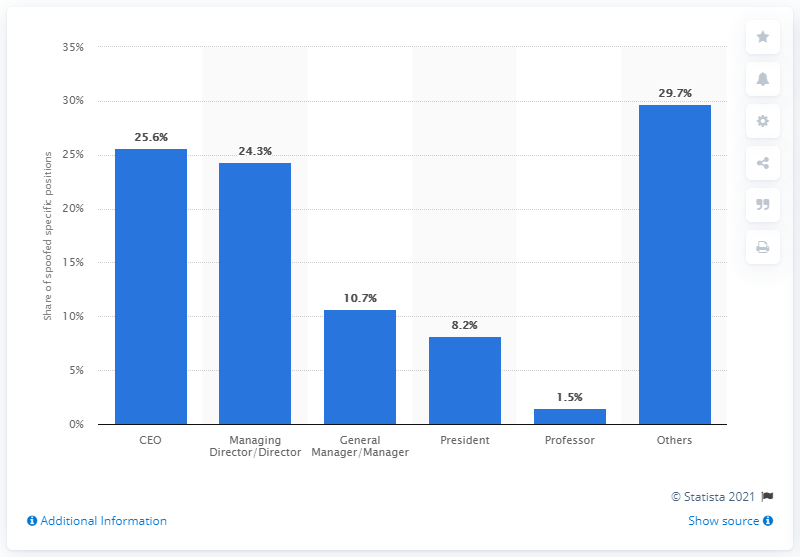What percentage of BEC scammers pretend to be CEOs of their victim companies?
 25.6 